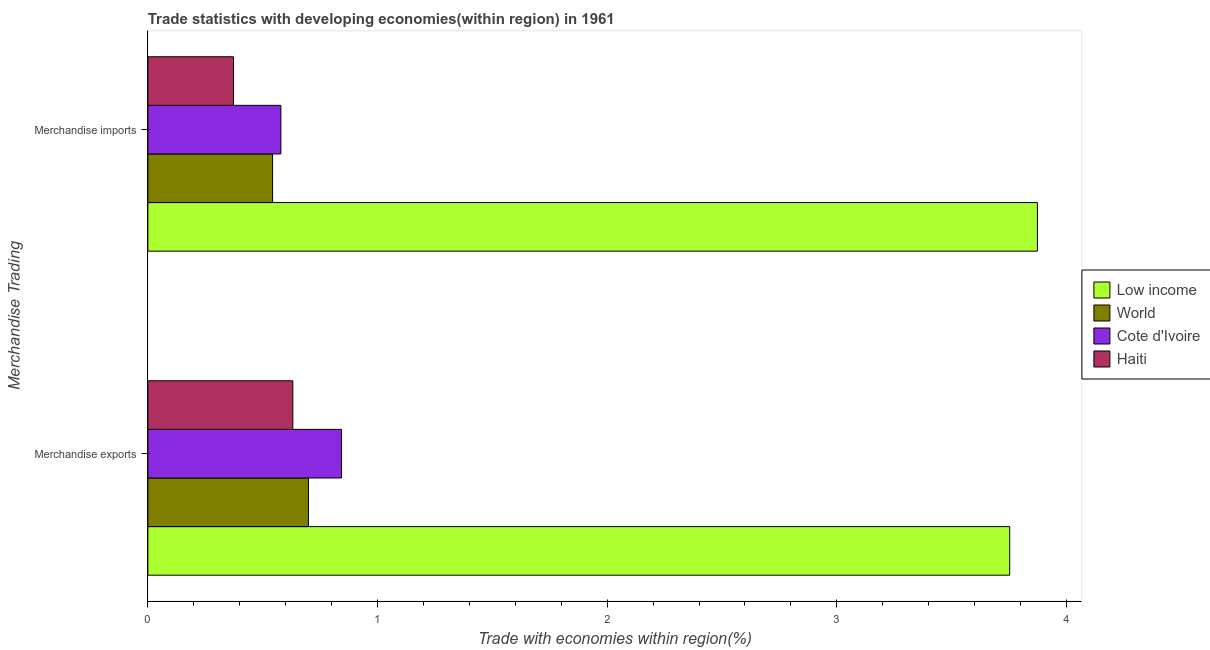How many different coloured bars are there?
Provide a succinct answer. 4. How many groups of bars are there?
Offer a very short reply. 2. Are the number of bars per tick equal to the number of legend labels?
Keep it short and to the point. Yes. Are the number of bars on each tick of the Y-axis equal?
Your answer should be compact. Yes. How many bars are there on the 2nd tick from the top?
Your response must be concise. 4. What is the label of the 2nd group of bars from the top?
Make the answer very short. Merchandise exports. What is the merchandise exports in World?
Your response must be concise. 0.7. Across all countries, what is the maximum merchandise imports?
Offer a very short reply. 3.87. Across all countries, what is the minimum merchandise exports?
Ensure brevity in your answer.  0.63. In which country was the merchandise imports minimum?
Ensure brevity in your answer.  Haiti. What is the total merchandise imports in the graph?
Your answer should be compact. 5.37. What is the difference between the merchandise exports in Low income and that in Cote d'Ivoire?
Ensure brevity in your answer.  2.91. What is the difference between the merchandise imports in Low income and the merchandise exports in Haiti?
Give a very brief answer. 3.24. What is the average merchandise exports per country?
Your answer should be compact. 1.48. What is the difference between the merchandise imports and merchandise exports in World?
Ensure brevity in your answer.  -0.16. What is the ratio of the merchandise exports in Haiti to that in Low income?
Your answer should be very brief. 0.17. What does the 4th bar from the bottom in Merchandise exports represents?
Provide a short and direct response. Haiti. How many countries are there in the graph?
Your answer should be very brief. 4. What is the difference between two consecutive major ticks on the X-axis?
Ensure brevity in your answer.  1. Are the values on the major ticks of X-axis written in scientific E-notation?
Keep it short and to the point. No. Does the graph contain grids?
Keep it short and to the point. No. Where does the legend appear in the graph?
Provide a short and direct response. Center right. How many legend labels are there?
Offer a terse response. 4. What is the title of the graph?
Provide a succinct answer. Trade statistics with developing economies(within region) in 1961. Does "Poland" appear as one of the legend labels in the graph?
Offer a terse response. No. What is the label or title of the X-axis?
Ensure brevity in your answer.  Trade with economies within region(%). What is the label or title of the Y-axis?
Give a very brief answer. Merchandise Trading. What is the Trade with economies within region(%) of Low income in Merchandise exports?
Offer a terse response. 3.75. What is the Trade with economies within region(%) of World in Merchandise exports?
Your response must be concise. 0.7. What is the Trade with economies within region(%) in Cote d'Ivoire in Merchandise exports?
Ensure brevity in your answer.  0.84. What is the Trade with economies within region(%) of Haiti in Merchandise exports?
Offer a very short reply. 0.63. What is the Trade with economies within region(%) of Low income in Merchandise imports?
Provide a succinct answer. 3.87. What is the Trade with economies within region(%) in World in Merchandise imports?
Your answer should be very brief. 0.54. What is the Trade with economies within region(%) of Cote d'Ivoire in Merchandise imports?
Ensure brevity in your answer.  0.58. What is the Trade with economies within region(%) of Haiti in Merchandise imports?
Keep it short and to the point. 0.37. Across all Merchandise Trading, what is the maximum Trade with economies within region(%) in Low income?
Give a very brief answer. 3.87. Across all Merchandise Trading, what is the maximum Trade with economies within region(%) of World?
Offer a very short reply. 0.7. Across all Merchandise Trading, what is the maximum Trade with economies within region(%) in Cote d'Ivoire?
Offer a very short reply. 0.84. Across all Merchandise Trading, what is the maximum Trade with economies within region(%) of Haiti?
Your response must be concise. 0.63. Across all Merchandise Trading, what is the minimum Trade with economies within region(%) of Low income?
Provide a short and direct response. 3.75. Across all Merchandise Trading, what is the minimum Trade with economies within region(%) in World?
Keep it short and to the point. 0.54. Across all Merchandise Trading, what is the minimum Trade with economies within region(%) in Cote d'Ivoire?
Offer a terse response. 0.58. Across all Merchandise Trading, what is the minimum Trade with economies within region(%) in Haiti?
Offer a terse response. 0.37. What is the total Trade with economies within region(%) in Low income in the graph?
Your answer should be compact. 7.63. What is the total Trade with economies within region(%) in World in the graph?
Offer a very short reply. 1.24. What is the total Trade with economies within region(%) in Cote d'Ivoire in the graph?
Ensure brevity in your answer.  1.42. What is the difference between the Trade with economies within region(%) of Low income in Merchandise exports and that in Merchandise imports?
Offer a very short reply. -0.12. What is the difference between the Trade with economies within region(%) of World in Merchandise exports and that in Merchandise imports?
Keep it short and to the point. 0.16. What is the difference between the Trade with economies within region(%) in Cote d'Ivoire in Merchandise exports and that in Merchandise imports?
Ensure brevity in your answer.  0.26. What is the difference between the Trade with economies within region(%) of Haiti in Merchandise exports and that in Merchandise imports?
Give a very brief answer. 0.26. What is the difference between the Trade with economies within region(%) in Low income in Merchandise exports and the Trade with economies within region(%) in World in Merchandise imports?
Make the answer very short. 3.21. What is the difference between the Trade with economies within region(%) in Low income in Merchandise exports and the Trade with economies within region(%) in Cote d'Ivoire in Merchandise imports?
Provide a short and direct response. 3.17. What is the difference between the Trade with economies within region(%) of Low income in Merchandise exports and the Trade with economies within region(%) of Haiti in Merchandise imports?
Provide a short and direct response. 3.38. What is the difference between the Trade with economies within region(%) in World in Merchandise exports and the Trade with economies within region(%) in Cote d'Ivoire in Merchandise imports?
Ensure brevity in your answer.  0.12. What is the difference between the Trade with economies within region(%) in World in Merchandise exports and the Trade with economies within region(%) in Haiti in Merchandise imports?
Your answer should be compact. 0.33. What is the difference between the Trade with economies within region(%) in Cote d'Ivoire in Merchandise exports and the Trade with economies within region(%) in Haiti in Merchandise imports?
Your answer should be very brief. 0.47. What is the average Trade with economies within region(%) of Low income per Merchandise Trading?
Provide a succinct answer. 3.81. What is the average Trade with economies within region(%) in World per Merchandise Trading?
Offer a terse response. 0.62. What is the average Trade with economies within region(%) in Cote d'Ivoire per Merchandise Trading?
Offer a terse response. 0.71. What is the average Trade with economies within region(%) of Haiti per Merchandise Trading?
Your answer should be very brief. 0.5. What is the difference between the Trade with economies within region(%) in Low income and Trade with economies within region(%) in World in Merchandise exports?
Provide a short and direct response. 3.05. What is the difference between the Trade with economies within region(%) in Low income and Trade with economies within region(%) in Cote d'Ivoire in Merchandise exports?
Your response must be concise. 2.91. What is the difference between the Trade with economies within region(%) of Low income and Trade with economies within region(%) of Haiti in Merchandise exports?
Offer a very short reply. 3.12. What is the difference between the Trade with economies within region(%) of World and Trade with economies within region(%) of Cote d'Ivoire in Merchandise exports?
Make the answer very short. -0.14. What is the difference between the Trade with economies within region(%) of World and Trade with economies within region(%) of Haiti in Merchandise exports?
Keep it short and to the point. 0.07. What is the difference between the Trade with economies within region(%) of Cote d'Ivoire and Trade with economies within region(%) of Haiti in Merchandise exports?
Give a very brief answer. 0.21. What is the difference between the Trade with economies within region(%) in Low income and Trade with economies within region(%) in World in Merchandise imports?
Give a very brief answer. 3.33. What is the difference between the Trade with economies within region(%) of Low income and Trade with economies within region(%) of Cote d'Ivoire in Merchandise imports?
Provide a succinct answer. 3.29. What is the difference between the Trade with economies within region(%) in Low income and Trade with economies within region(%) in Haiti in Merchandise imports?
Ensure brevity in your answer.  3.5. What is the difference between the Trade with economies within region(%) of World and Trade with economies within region(%) of Cote d'Ivoire in Merchandise imports?
Provide a short and direct response. -0.04. What is the difference between the Trade with economies within region(%) of World and Trade with economies within region(%) of Haiti in Merchandise imports?
Your answer should be compact. 0.17. What is the difference between the Trade with economies within region(%) in Cote d'Ivoire and Trade with economies within region(%) in Haiti in Merchandise imports?
Provide a short and direct response. 0.21. What is the ratio of the Trade with economies within region(%) of Low income in Merchandise exports to that in Merchandise imports?
Your answer should be compact. 0.97. What is the ratio of the Trade with economies within region(%) of World in Merchandise exports to that in Merchandise imports?
Provide a short and direct response. 1.29. What is the ratio of the Trade with economies within region(%) of Cote d'Ivoire in Merchandise exports to that in Merchandise imports?
Offer a terse response. 1.46. What is the ratio of the Trade with economies within region(%) of Haiti in Merchandise exports to that in Merchandise imports?
Keep it short and to the point. 1.69. What is the difference between the highest and the second highest Trade with economies within region(%) in Low income?
Your answer should be very brief. 0.12. What is the difference between the highest and the second highest Trade with economies within region(%) in World?
Your answer should be very brief. 0.16. What is the difference between the highest and the second highest Trade with economies within region(%) in Cote d'Ivoire?
Make the answer very short. 0.26. What is the difference between the highest and the second highest Trade with economies within region(%) of Haiti?
Your response must be concise. 0.26. What is the difference between the highest and the lowest Trade with economies within region(%) of Low income?
Your response must be concise. 0.12. What is the difference between the highest and the lowest Trade with economies within region(%) in World?
Make the answer very short. 0.16. What is the difference between the highest and the lowest Trade with economies within region(%) in Cote d'Ivoire?
Provide a succinct answer. 0.26. What is the difference between the highest and the lowest Trade with economies within region(%) in Haiti?
Give a very brief answer. 0.26. 